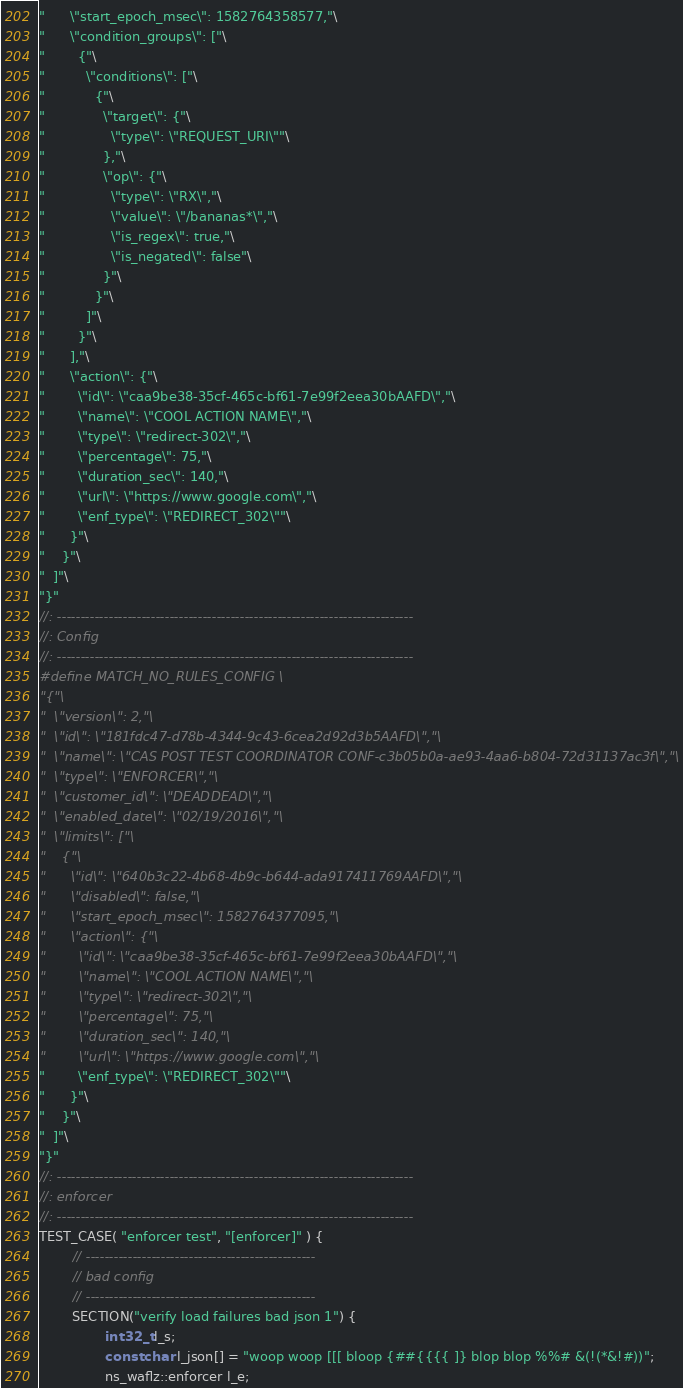<code> <loc_0><loc_0><loc_500><loc_500><_C++_>"      \"start_epoch_msec\": 1582764358577,"\
"      \"condition_groups\": ["\
"        {"\
"          \"conditions\": ["\
"            {"\
"              \"target\": {"\
"                \"type\": \"REQUEST_URI\""\
"              },"\
"              \"op\": {"\
"                \"type\": \"RX\","\
"                \"value\": \"/bananas*\","\
"                \"is_regex\": true,"\
"                \"is_negated\": false"\
"              }"\
"            }"\
"          ]"\
"        }"\
"      ],"\
"      \"action\": {"\
"        \"id\": \"caa9be38-35cf-465c-bf61-7e99f2eea30bAAFD\","\
"        \"name\": \"COOL ACTION NAME\","\
"        \"type\": \"redirect-302\","\
"        \"percentage\": 75,"\
"        \"duration_sec\": 140,"\
"        \"url\": \"https://www.google.com\","\
"        \"enf_type\": \"REDIRECT_302\""\
"      }"\
"    }"\
"  ]"\
"}"
//: ----------------------------------------------------------------------------
//: Config
//: ----------------------------------------------------------------------------
#define MATCH_NO_RULES_CONFIG \
"{"\
"  \"version\": 2,"\
"  \"id\": \"181fdc47-d78b-4344-9c43-6cea2d92d3b5AAFD\","\
"  \"name\": \"CAS POST TEST COORDINATOR CONF-c3b05b0a-ae93-4aa6-b804-72d31137ac3f\","\
"  \"type\": \"ENFORCER\","\
"  \"customer_id\": \"DEADDEAD\","\
"  \"enabled_date\": \"02/19/2016\","\
"  \"limits\": ["\
"    {"\
"      \"id\": \"640b3c22-4b68-4b9c-b644-ada917411769AAFD\","\
"      \"disabled\": false,"\
"      \"start_epoch_msec\": 1582764377095,"\
"      \"action\": {"\
"        \"id\": \"caa9be38-35cf-465c-bf61-7e99f2eea30bAAFD\","\
"        \"name\": \"COOL ACTION NAME\","\
"        \"type\": \"redirect-302\","\
"        \"percentage\": 75,"\
"        \"duration_sec\": 140,"\
"        \"url\": \"https://www.google.com\","\
"        \"enf_type\": \"REDIRECT_302\""\
"      }"\
"    }"\
"  ]"\
"}"
//: ----------------------------------------------------------------------------
//: enforcer
//: ----------------------------------------------------------------------------
TEST_CASE( "enforcer test", "[enforcer]" ) {
        // -------------------------------------------------
        // bad config
        // -------------------------------------------------
        SECTION("verify load failures bad json 1") {
                int32_t l_s;
                const char l_json[] = "woop woop [[[ bloop {##{{{{ ]} blop blop %%# &(!(*&!#))";
                ns_waflz::enforcer l_e;</code> 